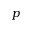Convert formula to latex. <formula><loc_0><loc_0><loc_500><loc_500>p</formula> 